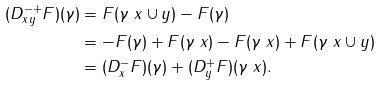<formula> <loc_0><loc_0><loc_500><loc_500>( D _ { x y } ^ { - + } F ) ( \gamma ) & = F ( \gamma \ x \cup y ) - F ( \gamma ) \\ & = - F ( \gamma ) + F ( \gamma \ x ) - F ( \gamma \ x ) + F ( \gamma \ x \cup y ) \\ & = ( D _ { x } ^ { - } F ) ( \gamma ) + ( D _ { y } ^ { + } F ) ( \gamma \ x ) .</formula> 